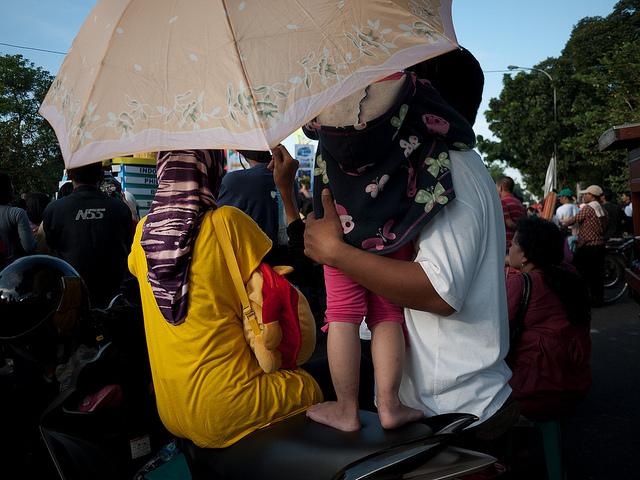What kind of animal can be seen in the picture?
Keep it brief. None. What hand can be seen?
Short answer required. Left. What logo is in the umbrella?
Keep it brief. None. Are these people inside?
Be succinct. No. What is over the child?
Keep it brief. Umbrella. What color is the dress and umbrella?
Keep it brief. Yellow. 